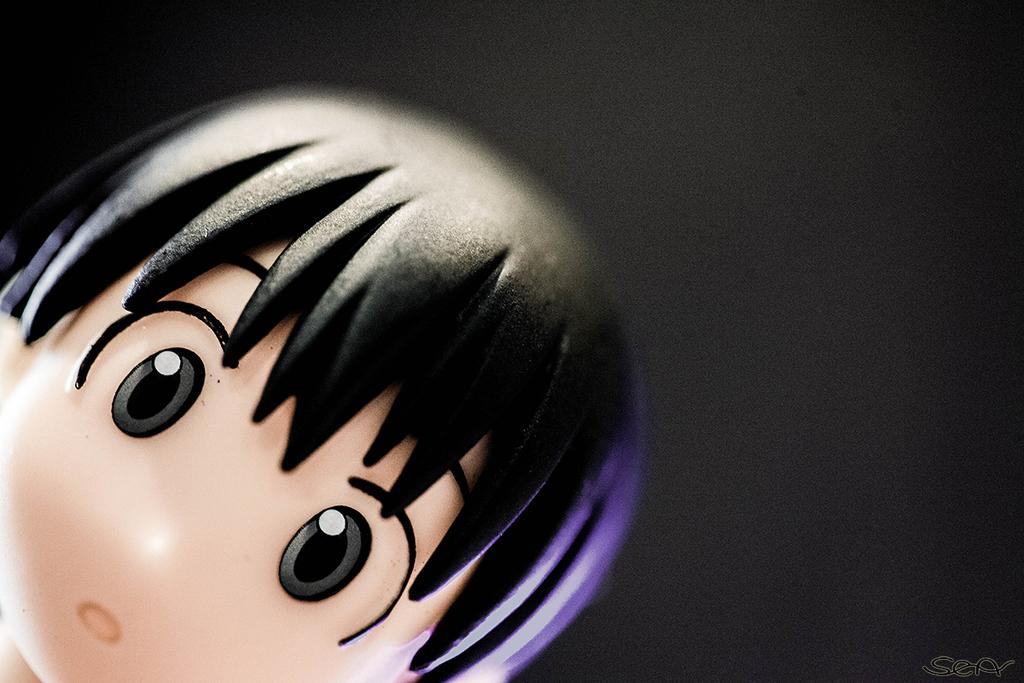What type of toy is present in the image? There is a toy in the image that resembles a person's head. Can you describe the background of the image? The background of the image is dark. What type of bubble can be seen floating in the image? There is no bubble present in the image. What type of laborer is working in the background of the image? There is no laborer present in the image, and the background is described as dark, not showing any specific activities or people. 